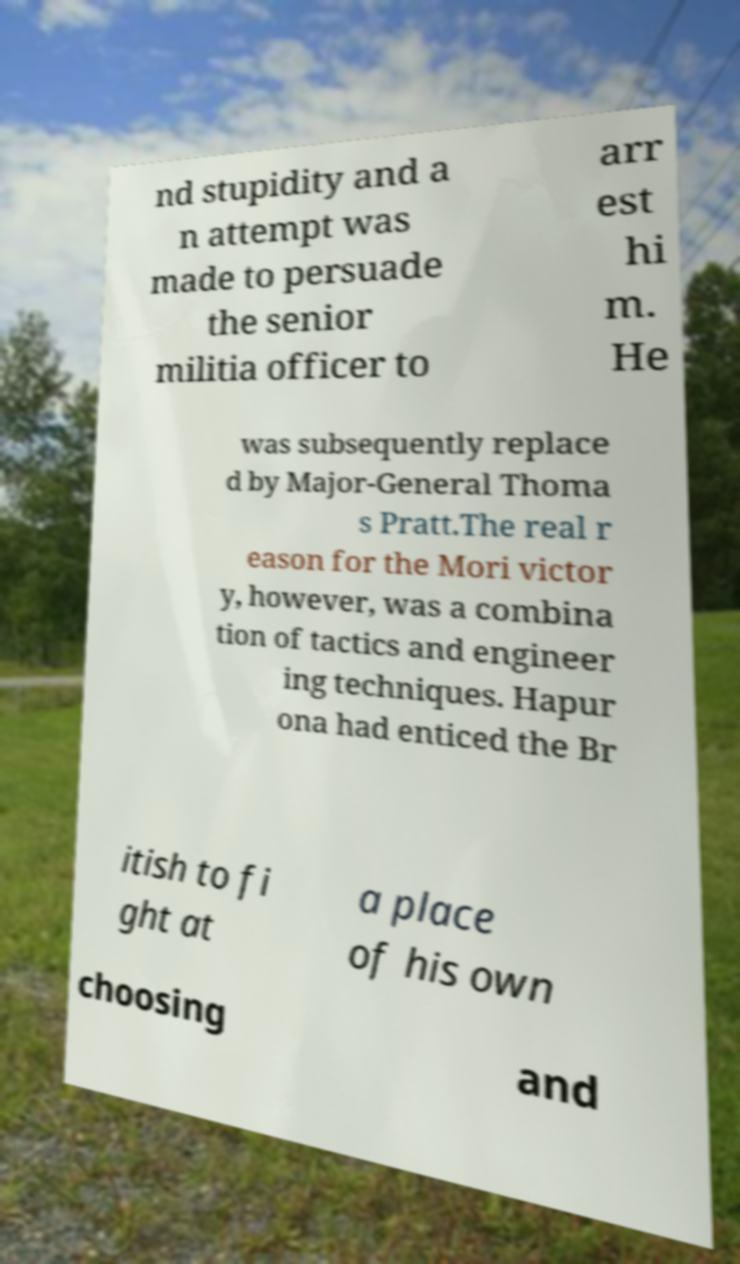Could you extract and type out the text from this image? nd stupidity and a n attempt was made to persuade the senior militia officer to arr est hi m. He was subsequently replace d by Major-General Thoma s Pratt.The real r eason for the Mori victor y, however, was a combina tion of tactics and engineer ing techniques. Hapur ona had enticed the Br itish to fi ght at a place of his own choosing and 